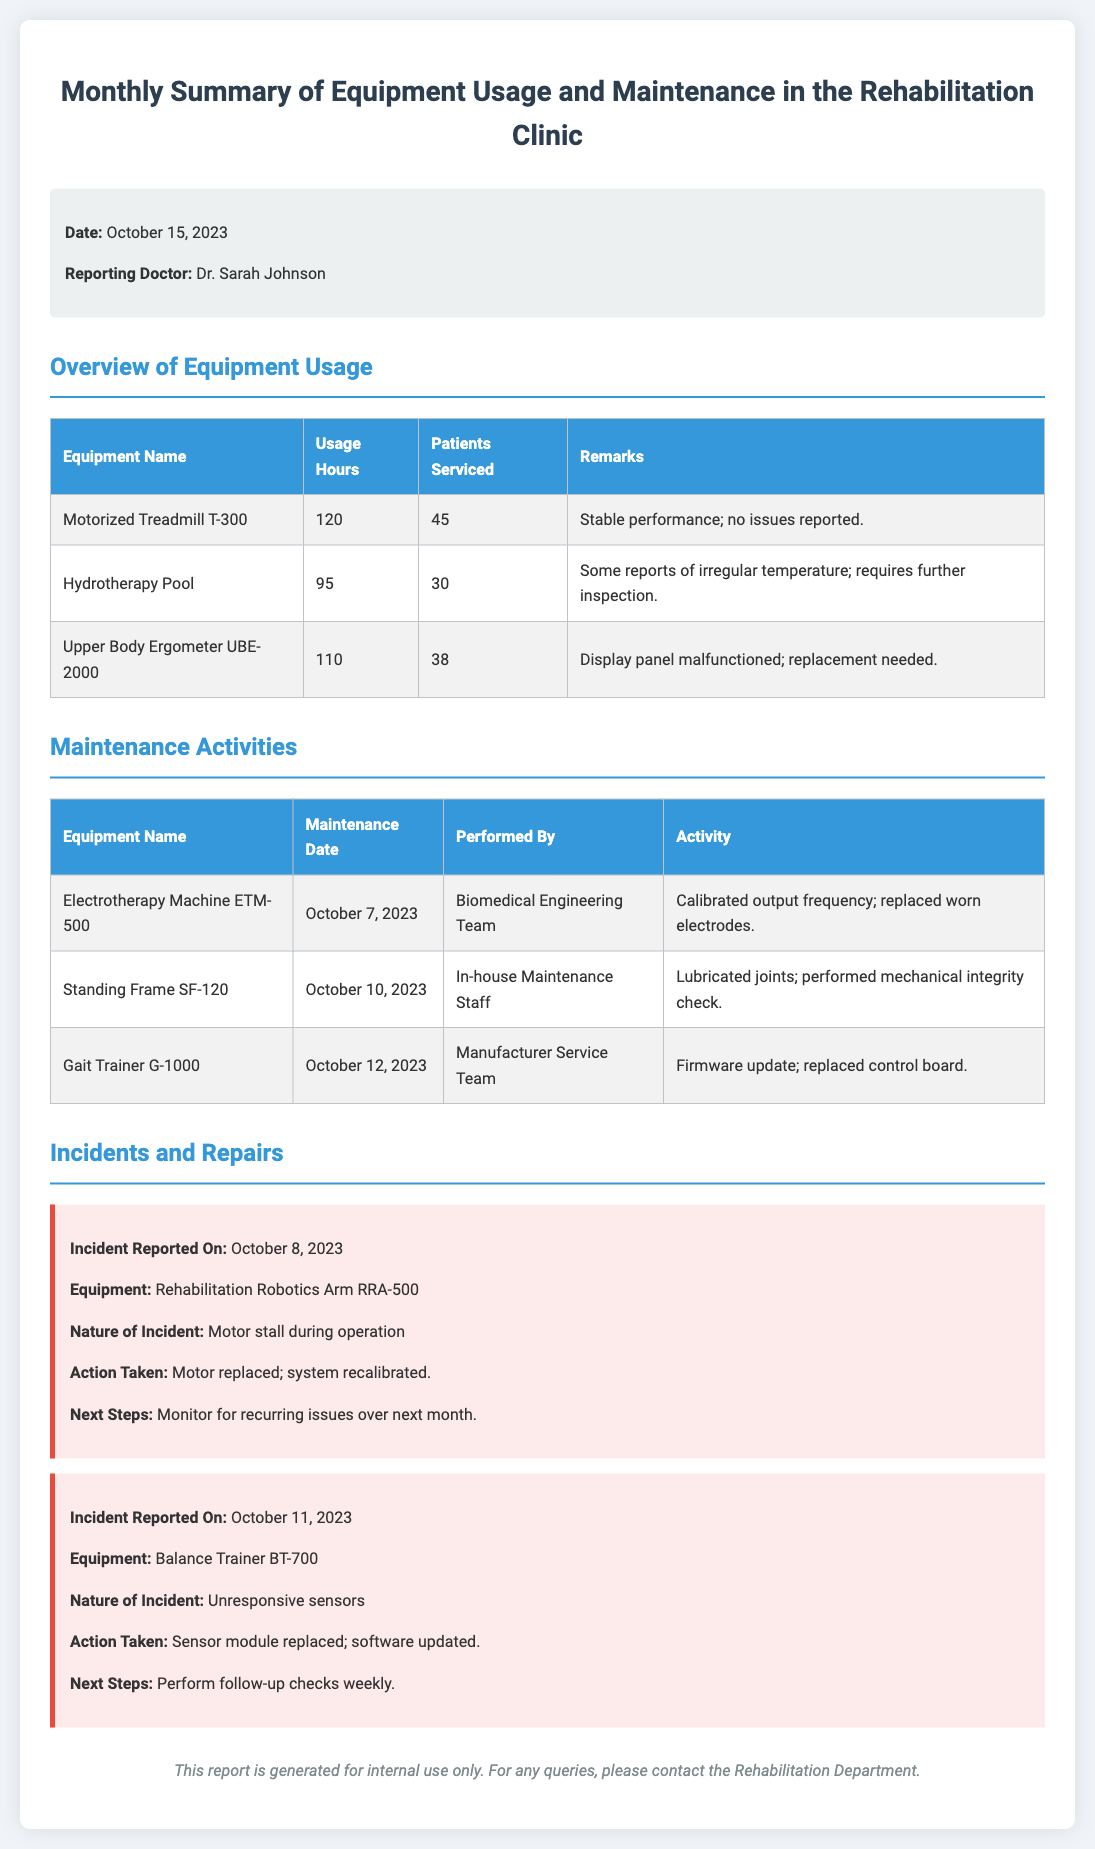What is the date of the report? The date of the report is mentioned in the information section at the top of the document.
Answer: October 15, 2023 Who is the reporting doctor? The reporting doctor is listed in the information section, indicating the person responsible for this report.
Answer: Dr. Sarah Johnson How many patients were serviced by the Hydrotherapy Pool? The number of patients serviced is listed in the overview table for the Hydrotherapy Pool.
Answer: 30 What incident occurred on October 8, 2023? The incident reported on October 8, 2023, is detailed in the incidents and repairs section of the document.
Answer: Motor stall during operation What maintenance activity was performed on the Electrotherapy Machine ETM-500? The maintenance activities for each equipment are listed in a dedicated table, detailing what was done.
Answer: Calibrated output frequency; replaced worn electrodes Which equipment showed a malfunction that required replacement? The overview table summarizes the issues for each piece of equipment, specifically mentioning the need for replacement.
Answer: Upper Body Ergometer UBE-2000 What is the next step after the incident with the Balance Trainer BT-700? The next steps after each incident are outlined in the incident reports, specifying follow-up actions needed.
Answer: Perform follow-up checks weekly How many hours did the Motorized Treadmill T-300 get used? The usage hours for the Motorized Treadmill T-300 are indicated in the overview table under usage hours.
Answer: 120 Who performed the maintenance on the Standing Frame SF-120? The maintenance personnel for each equipment are listed in the maintenance activities table.
Answer: In-house Maintenance Staff 